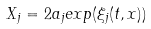<formula> <loc_0><loc_0><loc_500><loc_500>X _ { j } = 2 a _ { j } e x p ( \xi _ { j } ( t , x ) )</formula> 